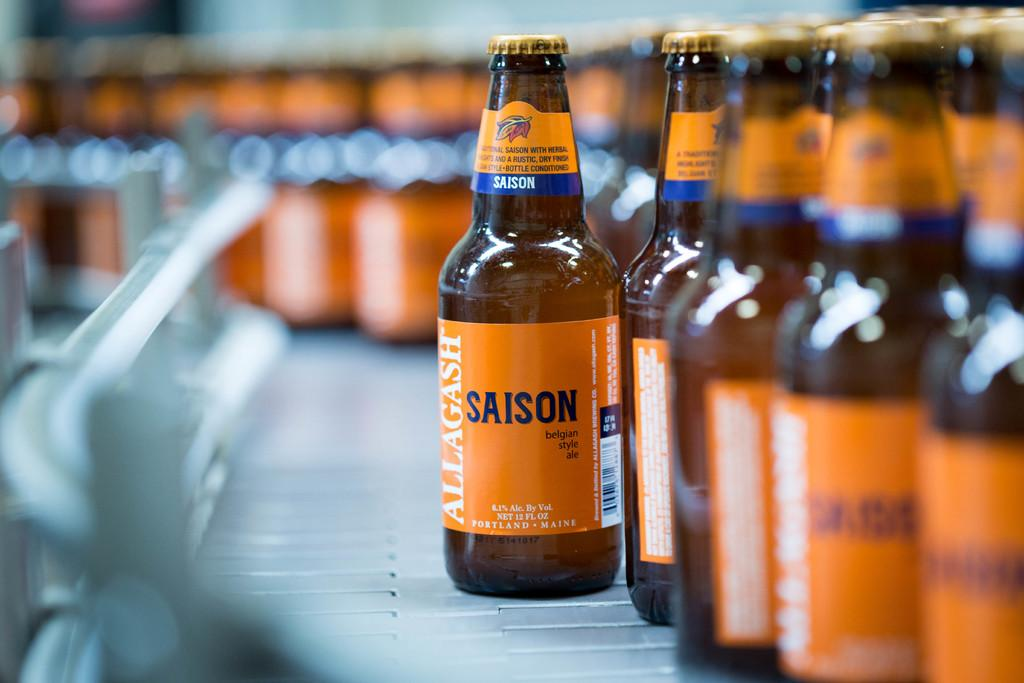<image>
Write a terse but informative summary of the picture. A conveyor belt with dozens of Allagash Saison beer bottles with orange labels going down it. 